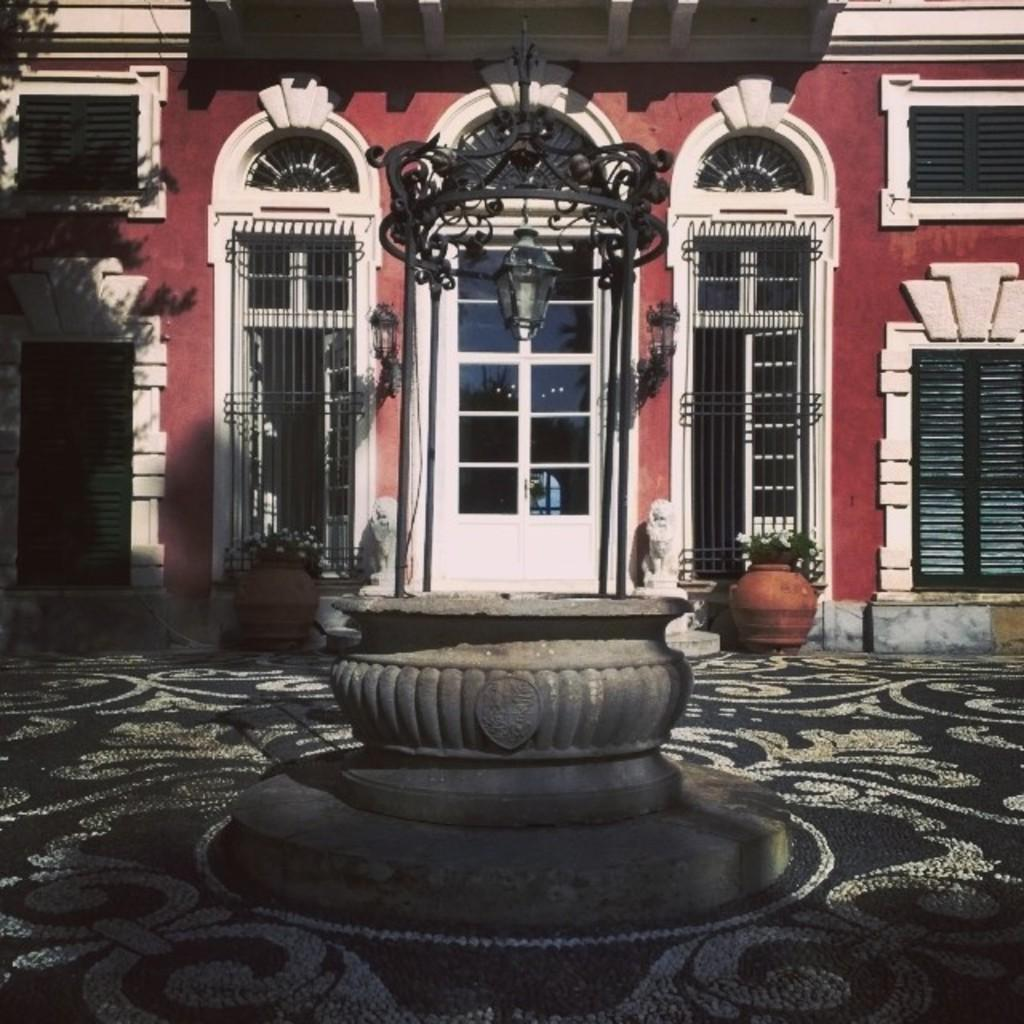What type of structure is visible in the image? There is a building in the image. What feature can be seen on the building? The building has windows. What is located in front of the building? There is a light in front of the building. How can people enter the building? There is a glass door in front of the building. What decorative elements are present near the building? There are flower pots on the floor on both sides of the building. What type of approval is required to enter the building's cellar in the image? There is no mention of a cellar or any approval process in the image. 